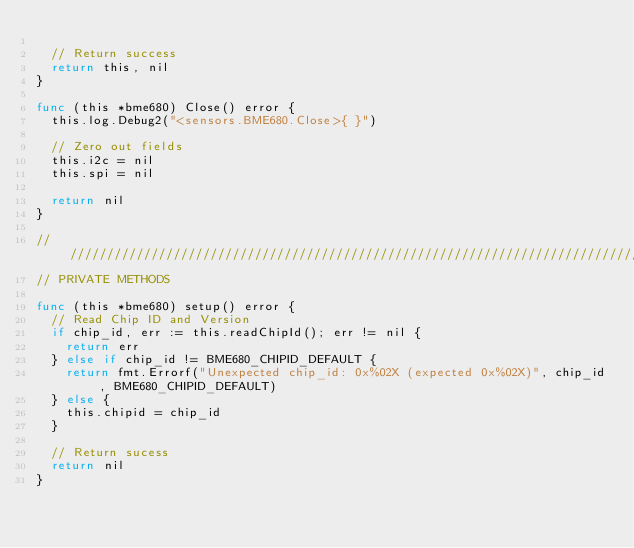Convert code to text. <code><loc_0><loc_0><loc_500><loc_500><_Go_>
	// Return success
	return this, nil
}

func (this *bme680) Close() error {
	this.log.Debug2("<sensors.BME680.Close>{ }")

	// Zero out fields
	this.i2c = nil
	this.spi = nil

	return nil
}

////////////////////////////////////////////////////////////////////////////////
// PRIVATE METHODS

func (this *bme680) setup() error {
	// Read Chip ID and Version
	if chip_id, err := this.readChipId(); err != nil {
		return err
	} else if chip_id != BME680_CHIPID_DEFAULT {
		return fmt.Errorf("Unexpected chip_id: 0x%02X (expected 0x%02X)", chip_id, BME680_CHIPID_DEFAULT)
	} else {
		this.chipid = chip_id
	}

	// Return sucess
	return nil
}
</code> 